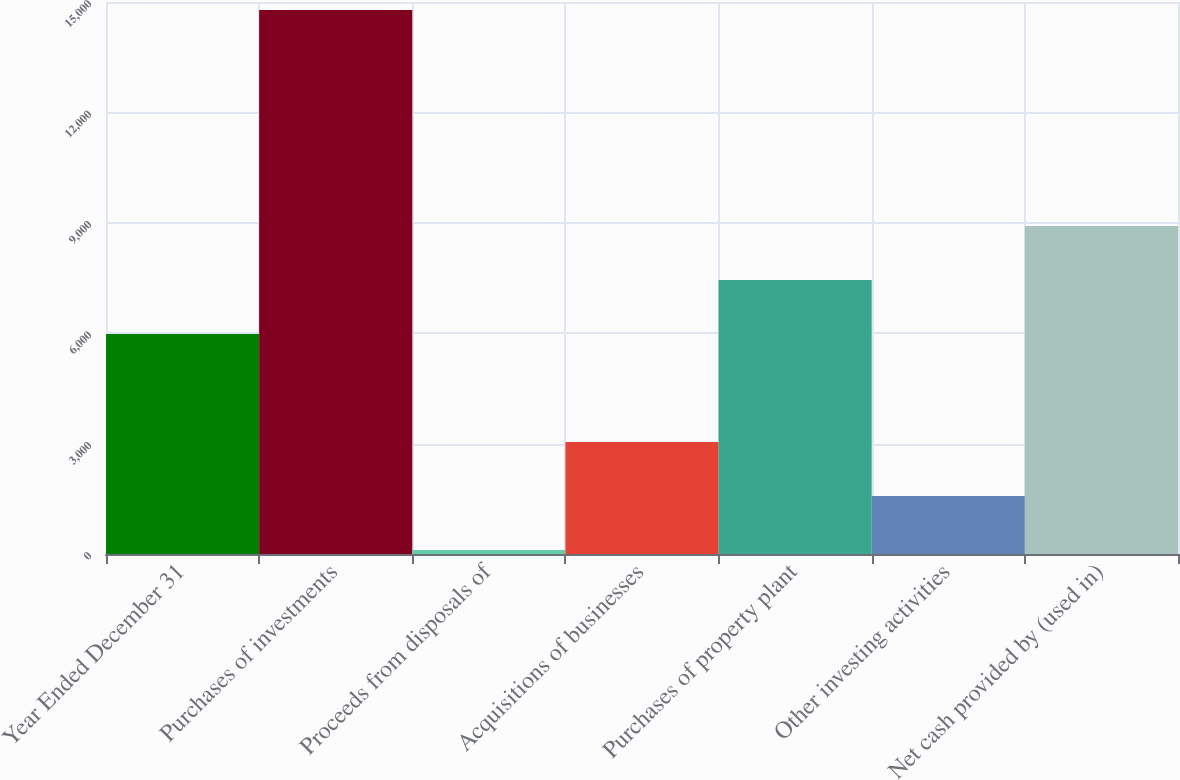<chart> <loc_0><loc_0><loc_500><loc_500><bar_chart><fcel>Year Ended December 31<fcel>Purchases of investments<fcel>Proceeds from disposals of<fcel>Acquisitions of businesses<fcel>Purchases of property plant<fcel>Other investing activities<fcel>Net cash provided by (used in)<nl><fcel>5979.4<fcel>14782<fcel>111<fcel>3045.2<fcel>7446.5<fcel>1578.1<fcel>8913.6<nl></chart> 